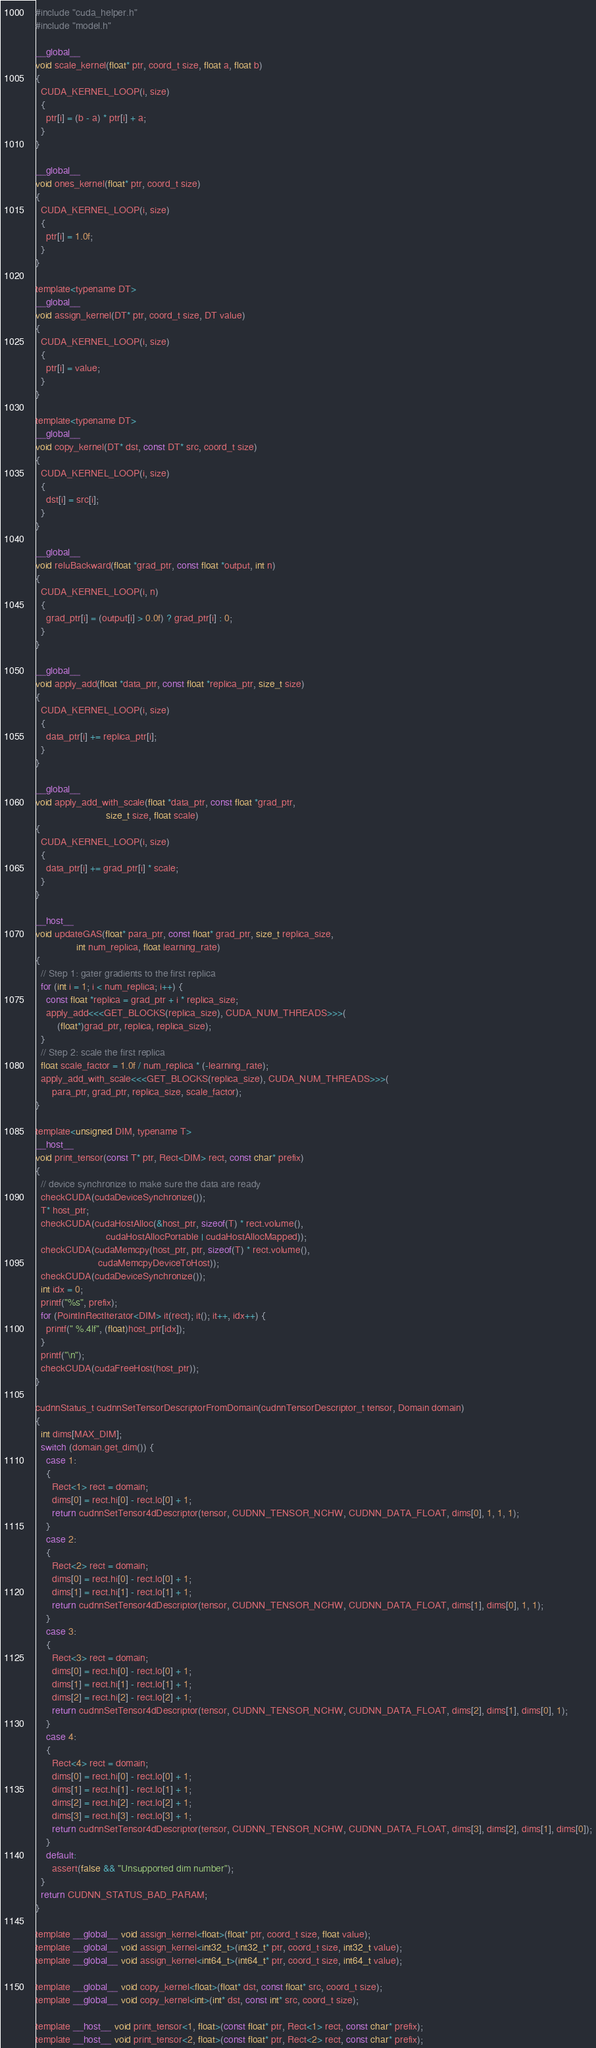<code> <loc_0><loc_0><loc_500><loc_500><_Cuda_>#include "cuda_helper.h"
#include "model.h"

__global__
void scale_kernel(float* ptr, coord_t size, float a, float b)
{
  CUDA_KERNEL_LOOP(i, size)
  {
    ptr[i] = (b - a) * ptr[i] + a;
  }
}

__global__
void ones_kernel(float* ptr, coord_t size)
{
  CUDA_KERNEL_LOOP(i, size)
  {
    ptr[i] = 1.0f;
  }
}

template<typename DT>
__global__
void assign_kernel(DT* ptr, coord_t size, DT value)
{
  CUDA_KERNEL_LOOP(i, size)
  {
    ptr[i] = value;
  }
}

template<typename DT>
__global__
void copy_kernel(DT* dst, const DT* src, coord_t size)
{
  CUDA_KERNEL_LOOP(i, size)
  {
    dst[i] = src[i];
  }
}

__global__
void reluBackward(float *grad_ptr, const float *output, int n)
{
  CUDA_KERNEL_LOOP(i, n)
  {
    grad_ptr[i] = (output[i] > 0.0f) ? grad_ptr[i] : 0;
  }
}

__global__
void apply_add(float *data_ptr, const float *replica_ptr, size_t size)
{
  CUDA_KERNEL_LOOP(i, size)
  {
    data_ptr[i] += replica_ptr[i];   
  }
}

__global__
void apply_add_with_scale(float *data_ptr, const float *grad_ptr,
                          size_t size, float scale)
{
  CUDA_KERNEL_LOOP(i, size)
  {
    data_ptr[i] += grad_ptr[i] * scale;
  }
}

__host__
void updateGAS(float* para_ptr, const float* grad_ptr, size_t replica_size,
               int num_replica, float learning_rate)
{
  // Step 1: gater gradients to the first replica
  for (int i = 1; i < num_replica; i++) {
    const float *replica = grad_ptr + i * replica_size;
    apply_add<<<GET_BLOCKS(replica_size), CUDA_NUM_THREADS>>>(
        (float*)grad_ptr, replica, replica_size);
  }
  // Step 2: scale the first replica
  float scale_factor = 1.0f / num_replica * (-learning_rate);
  apply_add_with_scale<<<GET_BLOCKS(replica_size), CUDA_NUM_THREADS>>>(
      para_ptr, grad_ptr, replica_size, scale_factor);
}

template<unsigned DIM, typename T>
__host__
void print_tensor(const T* ptr, Rect<DIM> rect, const char* prefix)
{
  // device synchronize to make sure the data are ready
  checkCUDA(cudaDeviceSynchronize());
  T* host_ptr;
  checkCUDA(cudaHostAlloc(&host_ptr, sizeof(T) * rect.volume(),
                          cudaHostAllocPortable | cudaHostAllocMapped));
  checkCUDA(cudaMemcpy(host_ptr, ptr, sizeof(T) * rect.volume(),
                       cudaMemcpyDeviceToHost));
  checkCUDA(cudaDeviceSynchronize());
  int idx = 0;
  printf("%s", prefix);
  for (PointInRectIterator<DIM> it(rect); it(); it++, idx++) {
    printf(" %.4lf", (float)host_ptr[idx]);
  }
  printf("\n");
  checkCUDA(cudaFreeHost(host_ptr));
}

cudnnStatus_t cudnnSetTensorDescriptorFromDomain(cudnnTensorDescriptor_t tensor, Domain domain)
{
  int dims[MAX_DIM];
  switch (domain.get_dim()) {
    case 1:
    {
      Rect<1> rect = domain;
      dims[0] = rect.hi[0] - rect.lo[0] + 1;
      return cudnnSetTensor4dDescriptor(tensor, CUDNN_TENSOR_NCHW, CUDNN_DATA_FLOAT, dims[0], 1, 1, 1);
    }
    case 2:
    {
      Rect<2> rect = domain;
      dims[0] = rect.hi[0] - rect.lo[0] + 1;
      dims[1] = rect.hi[1] - rect.lo[1] + 1;
      return cudnnSetTensor4dDescriptor(tensor, CUDNN_TENSOR_NCHW, CUDNN_DATA_FLOAT, dims[1], dims[0], 1, 1);
    }
    case 3:
    {
      Rect<3> rect = domain;
      dims[0] = rect.hi[0] - rect.lo[0] + 1;
      dims[1] = rect.hi[1] - rect.lo[1] + 1;
      dims[2] = rect.hi[2] - rect.lo[2] + 1;
      return cudnnSetTensor4dDescriptor(tensor, CUDNN_TENSOR_NCHW, CUDNN_DATA_FLOAT, dims[2], dims[1], dims[0], 1);
    }
    case 4:
    {
      Rect<4> rect = domain;
      dims[0] = rect.hi[0] - rect.lo[0] + 1;
      dims[1] = rect.hi[1] - rect.lo[1] + 1;
      dims[2] = rect.hi[2] - rect.lo[2] + 1;
      dims[3] = rect.hi[3] - rect.lo[3] + 1;
      return cudnnSetTensor4dDescriptor(tensor, CUDNN_TENSOR_NCHW, CUDNN_DATA_FLOAT, dims[3], dims[2], dims[1], dims[0]);
    }
    default:
      assert(false && "Unsupported dim number");
  }
  return CUDNN_STATUS_BAD_PARAM;
}

template __global__ void assign_kernel<float>(float* ptr, coord_t size, float value);
template __global__ void assign_kernel<int32_t>(int32_t* ptr, coord_t size, int32_t value);
template __global__ void assign_kernel<int64_t>(int64_t* ptr, coord_t size, int64_t value);

template __global__ void copy_kernel<float>(float* dst, const float* src, coord_t size);
template __global__ void copy_kernel<int>(int* dst, const int* src, coord_t size);

template __host__ void print_tensor<1, float>(const float* ptr, Rect<1> rect, const char* prefix);
template __host__ void print_tensor<2, float>(const float* ptr, Rect<2> rect, const char* prefix);</code> 